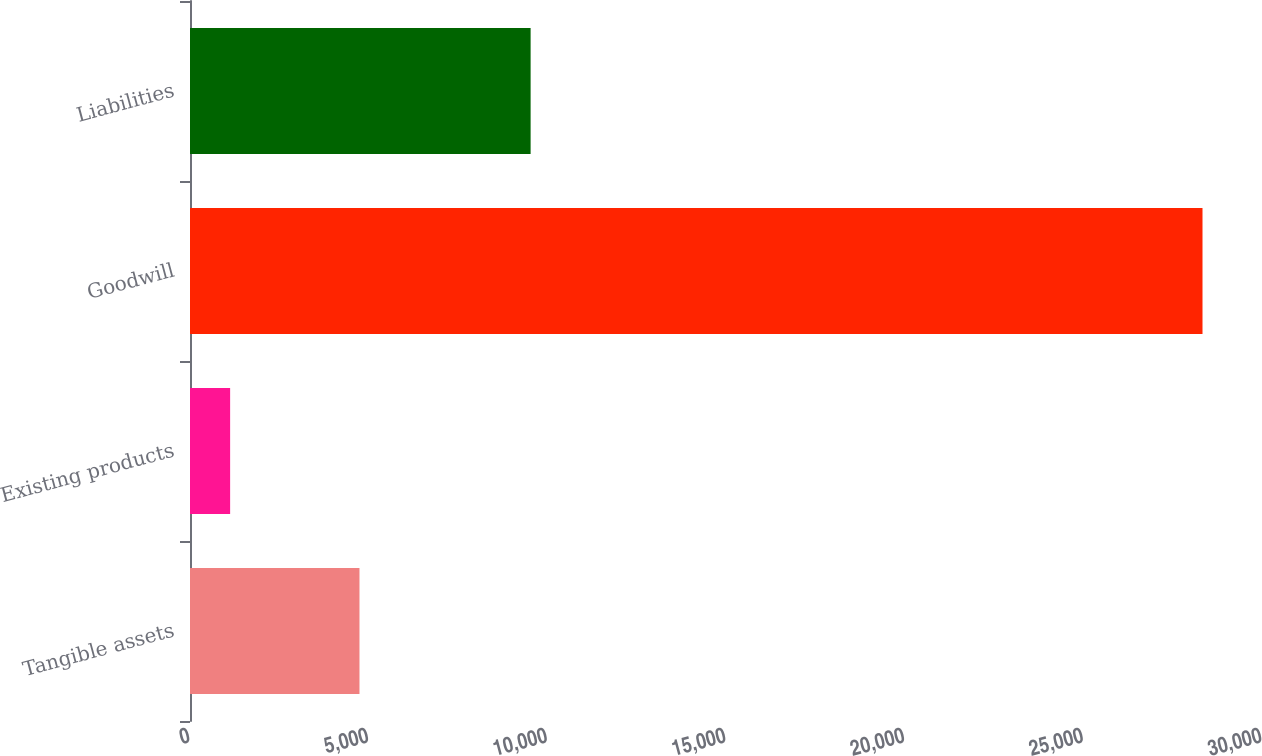<chart> <loc_0><loc_0><loc_500><loc_500><bar_chart><fcel>Tangible assets<fcel>Existing products<fcel>Goodwill<fcel>Liabilities<nl><fcel>4743<fcel>1123<fcel>28335<fcel>9532<nl></chart> 